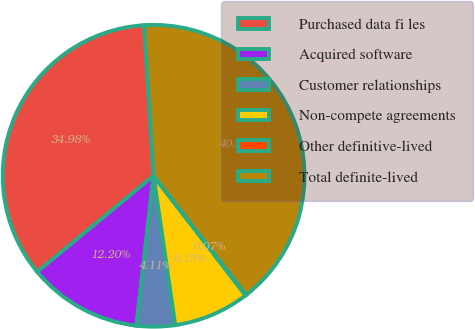<chart> <loc_0><loc_0><loc_500><loc_500><pie_chart><fcel>Purchased data fi les<fcel>Acquired software<fcel>Customer relationships<fcel>Non-compete agreements<fcel>Other definitive-lived<fcel>Total definite-lived<nl><fcel>34.98%<fcel>12.2%<fcel>4.11%<fcel>8.15%<fcel>0.07%<fcel>40.49%<nl></chart> 